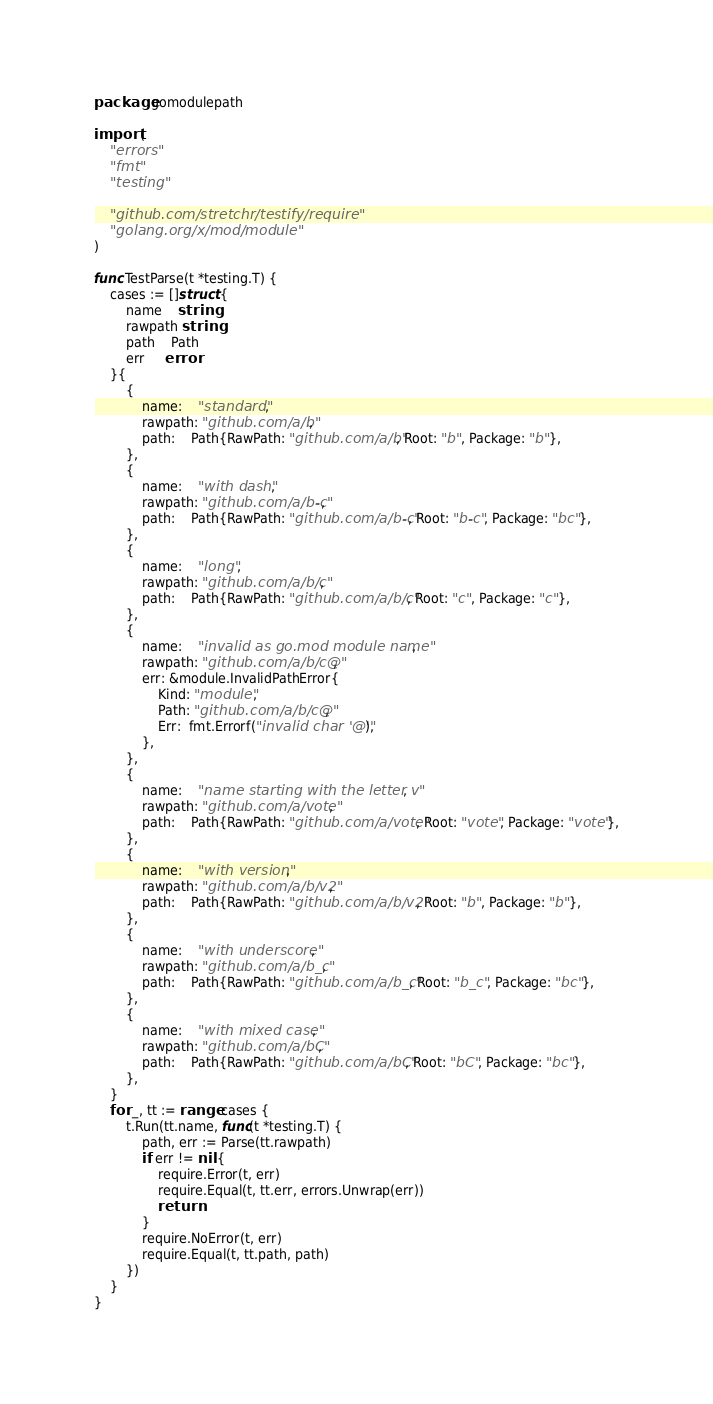<code> <loc_0><loc_0><loc_500><loc_500><_Go_>package gomodulepath

import (
	"errors"
	"fmt"
	"testing"

	"github.com/stretchr/testify/require"
	"golang.org/x/mod/module"
)

func TestParse(t *testing.T) {
	cases := []struct {
		name    string
		rawpath string
		path    Path
		err     error
	}{
		{
			name:    "standard",
			rawpath: "github.com/a/b",
			path:    Path{RawPath: "github.com/a/b", Root: "b", Package: "b"},
		},
		{
			name:    "with dash",
			rawpath: "github.com/a/b-c",
			path:    Path{RawPath: "github.com/a/b-c", Root: "b-c", Package: "bc"},
		},
		{
			name:    "long",
			rawpath: "github.com/a/b/c",
			path:    Path{RawPath: "github.com/a/b/c", Root: "c", Package: "c"},
		},
		{
			name:    "invalid as go.mod module name",
			rawpath: "github.com/a/b/c@",
			err: &module.InvalidPathError{
				Kind: "module",
				Path: "github.com/a/b/c@",
				Err:  fmt.Errorf("invalid char '@'"),
			},
		},
		{
			name:    "name starting with the letter v",
			rawpath: "github.com/a/vote",
			path:    Path{RawPath: "github.com/a/vote", Root: "vote", Package: "vote"},
		},
		{
			name:    "with version",
			rawpath: "github.com/a/b/v2",
			path:    Path{RawPath: "github.com/a/b/v2", Root: "b", Package: "b"},
		},
		{
			name:    "with underscore",
			rawpath: "github.com/a/b_c",
			path:    Path{RawPath: "github.com/a/b_c", Root: "b_c", Package: "bc"},
		},
		{
			name:    "with mixed case",
			rawpath: "github.com/a/bC",
			path:    Path{RawPath: "github.com/a/bC", Root: "bC", Package: "bc"},
		},
	}
	for _, tt := range cases {
		t.Run(tt.name, func(t *testing.T) {
			path, err := Parse(tt.rawpath)
			if err != nil {
				require.Error(t, err)
				require.Equal(t, tt.err, errors.Unwrap(err))
				return
			}
			require.NoError(t, err)
			require.Equal(t, tt.path, path)
		})
	}
}
</code> 